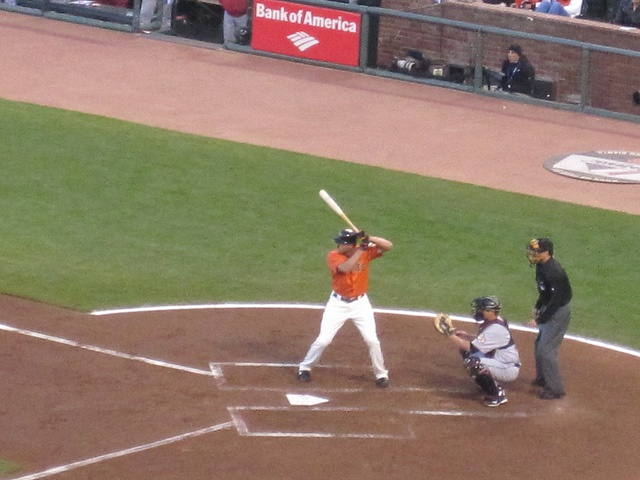Describe the objects in this image and their specific colors. I can see people in gray, white, brown, and red tones, people in gray and black tones, people in gray, lavender, darkgray, and black tones, people in gray and black tones, and people in gray and black tones in this image. 